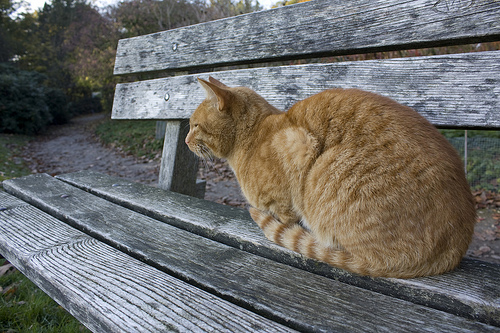What is the bench made of? The bench is constructed from wood, showcasing a rustic and natural look. 